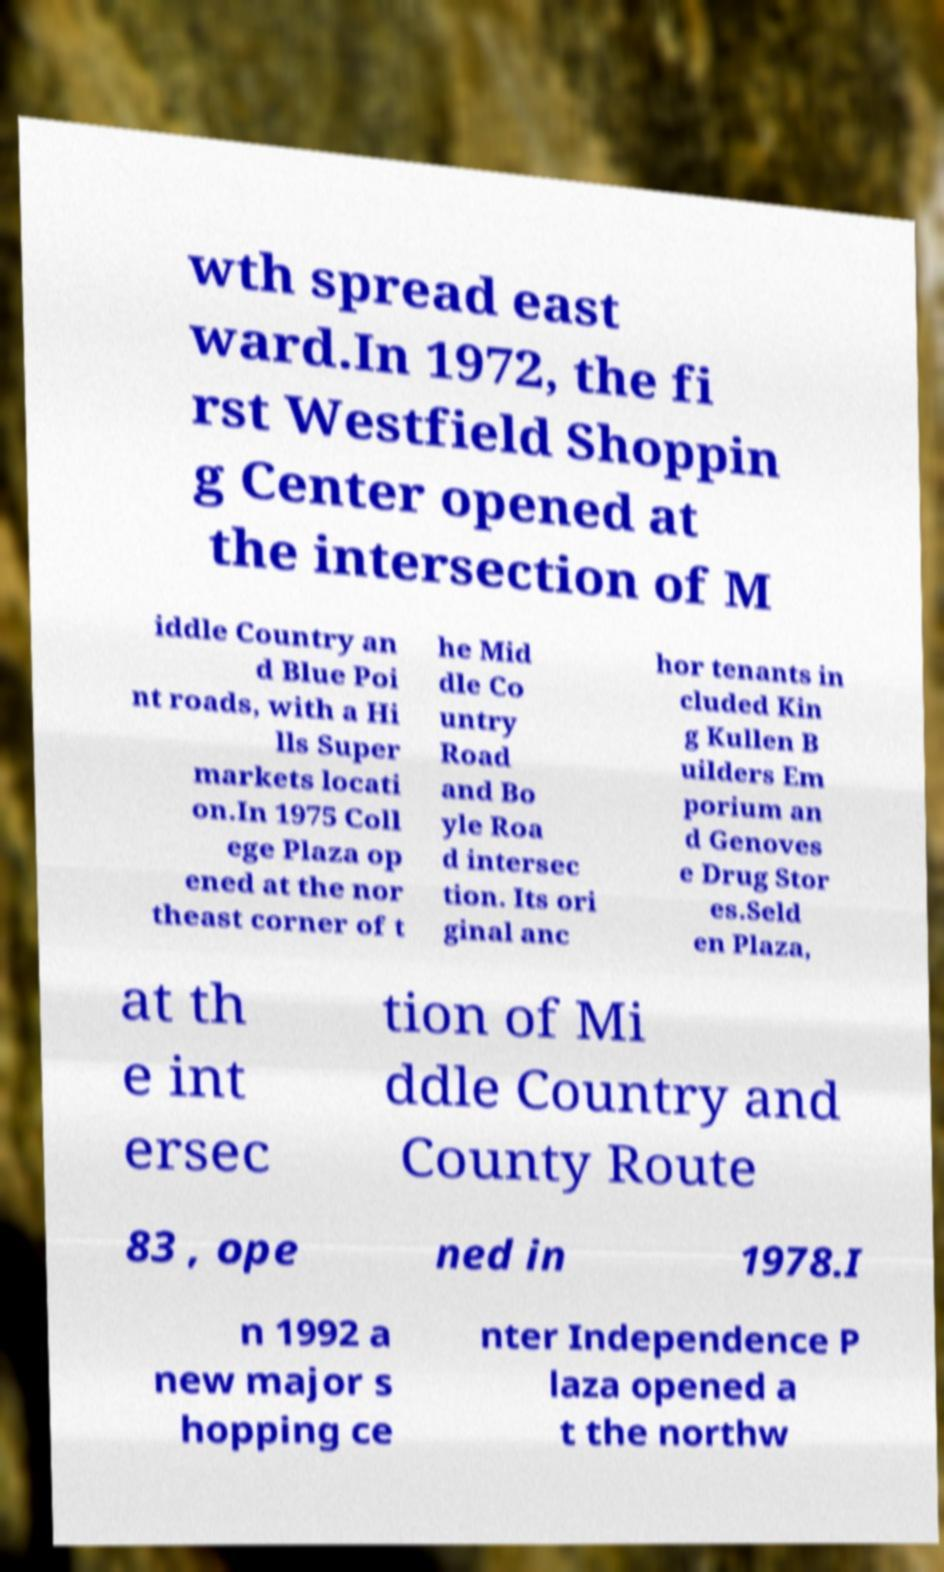I need the written content from this picture converted into text. Can you do that? wth spread east ward.In 1972, the fi rst Westfield Shoppin g Center opened at the intersection of M iddle Country an d Blue Poi nt roads, with a Hi lls Super markets locati on.In 1975 Coll ege Plaza op ened at the nor theast corner of t he Mid dle Co untry Road and Bo yle Roa d intersec tion. Its ori ginal anc hor tenants in cluded Kin g Kullen B uilders Em porium an d Genoves e Drug Stor es.Seld en Plaza, at th e int ersec tion of Mi ddle Country and County Route 83 , ope ned in 1978.I n 1992 a new major s hopping ce nter Independence P laza opened a t the northw 